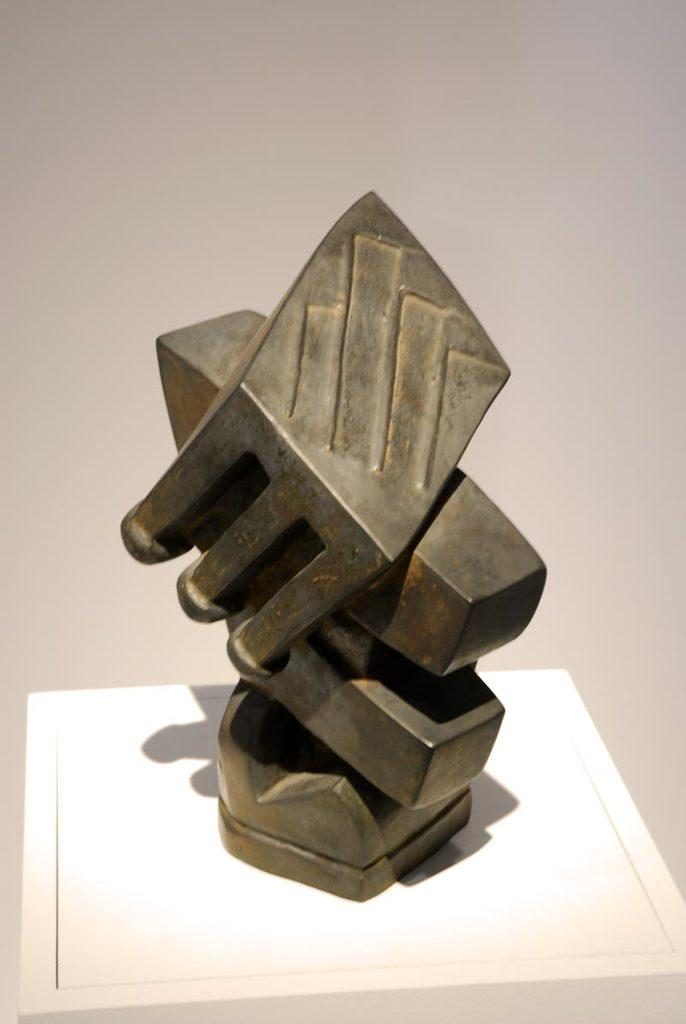What is located at the bottom of the image? There is a table at the bottom of the image. What is on top of the table? There is a metal object on the table. What can be seen behind the metal object? There is a wall visible behind the metal object. Can you see a giraffe standing next to the wall in the image? No, there is no giraffe present in the image. 